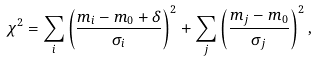Convert formula to latex. <formula><loc_0><loc_0><loc_500><loc_500>\chi ^ { 2 } = \sum _ { i } \left ( \frac { m _ { i } - m _ { 0 } + \delta } { \sigma _ { i } } \right ) ^ { 2 } + \sum _ { j } \left ( \frac { m _ { j } - m _ { 0 } } { \sigma _ { j } } \right ) ^ { 2 } ,</formula> 